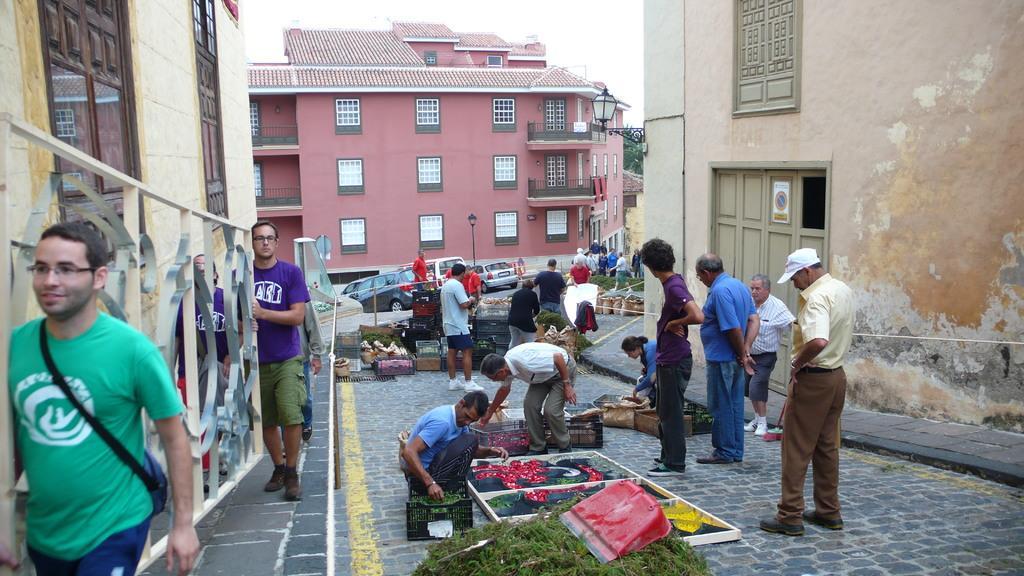Can you describe this image briefly? This is an outside view. Here I can see few people standing on the road. Along with the persons I can see few boards, boxes, leaves and some other objects. It seems like they are doing some art on the road. On the left side, I can see two men are holding a metal object in the hands and walking on the footpath. On both sides of the road I can see the buildings. 